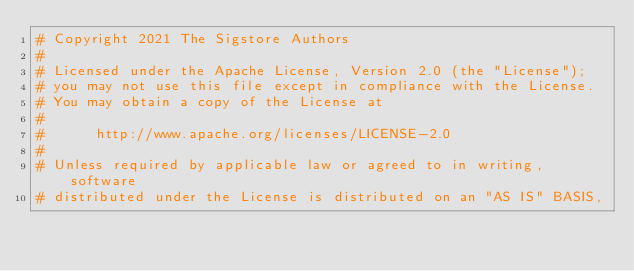Convert code to text. <code><loc_0><loc_0><loc_500><loc_500><_YAML_># Copyright 2021 The Sigstore Authors
#
# Licensed under the Apache License, Version 2.0 (the "License");
# you may not use this file except in compliance with the License.
# You may obtain a copy of the License at
#
#      http://www.apache.org/licenses/LICENSE-2.0
#
# Unless required by applicable law or agreed to in writing, software
# distributed under the License is distributed on an "AS IS" BASIS,</code> 